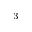<formula> <loc_0><loc_0><loc_500><loc_500>^ { 3 }</formula> 